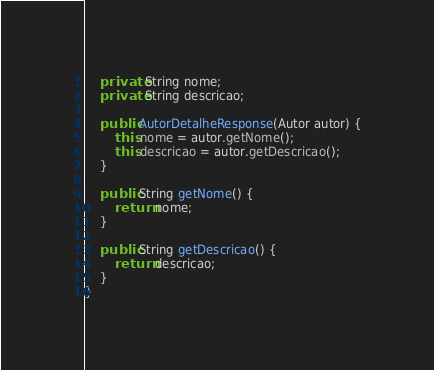Convert code to text. <code><loc_0><loc_0><loc_500><loc_500><_Java_>	private String nome;
	private String descricao;
	
	public AutorDetalheResponse(Autor autor) {
		this.nome = autor.getNome();
		this.descricao = autor.getDescricao();
	}

	public String getNome() {
		return nome;
	}

	public String getDescricao() {
		return descricao;
	}
}
</code> 